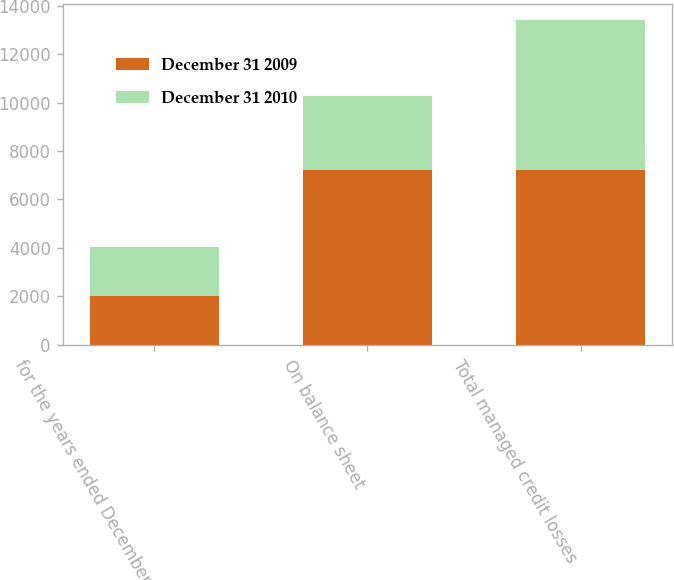<chart> <loc_0><loc_0><loc_500><loc_500><stacked_bar_chart><ecel><fcel>for the years ended December<fcel>On balance sheet<fcel>Total managed credit losses<nl><fcel>December 31 2009<fcel>2010<fcel>7230<fcel>7230<nl><fcel>December 31 2010<fcel>2008<fcel>3052<fcel>6159<nl></chart> 